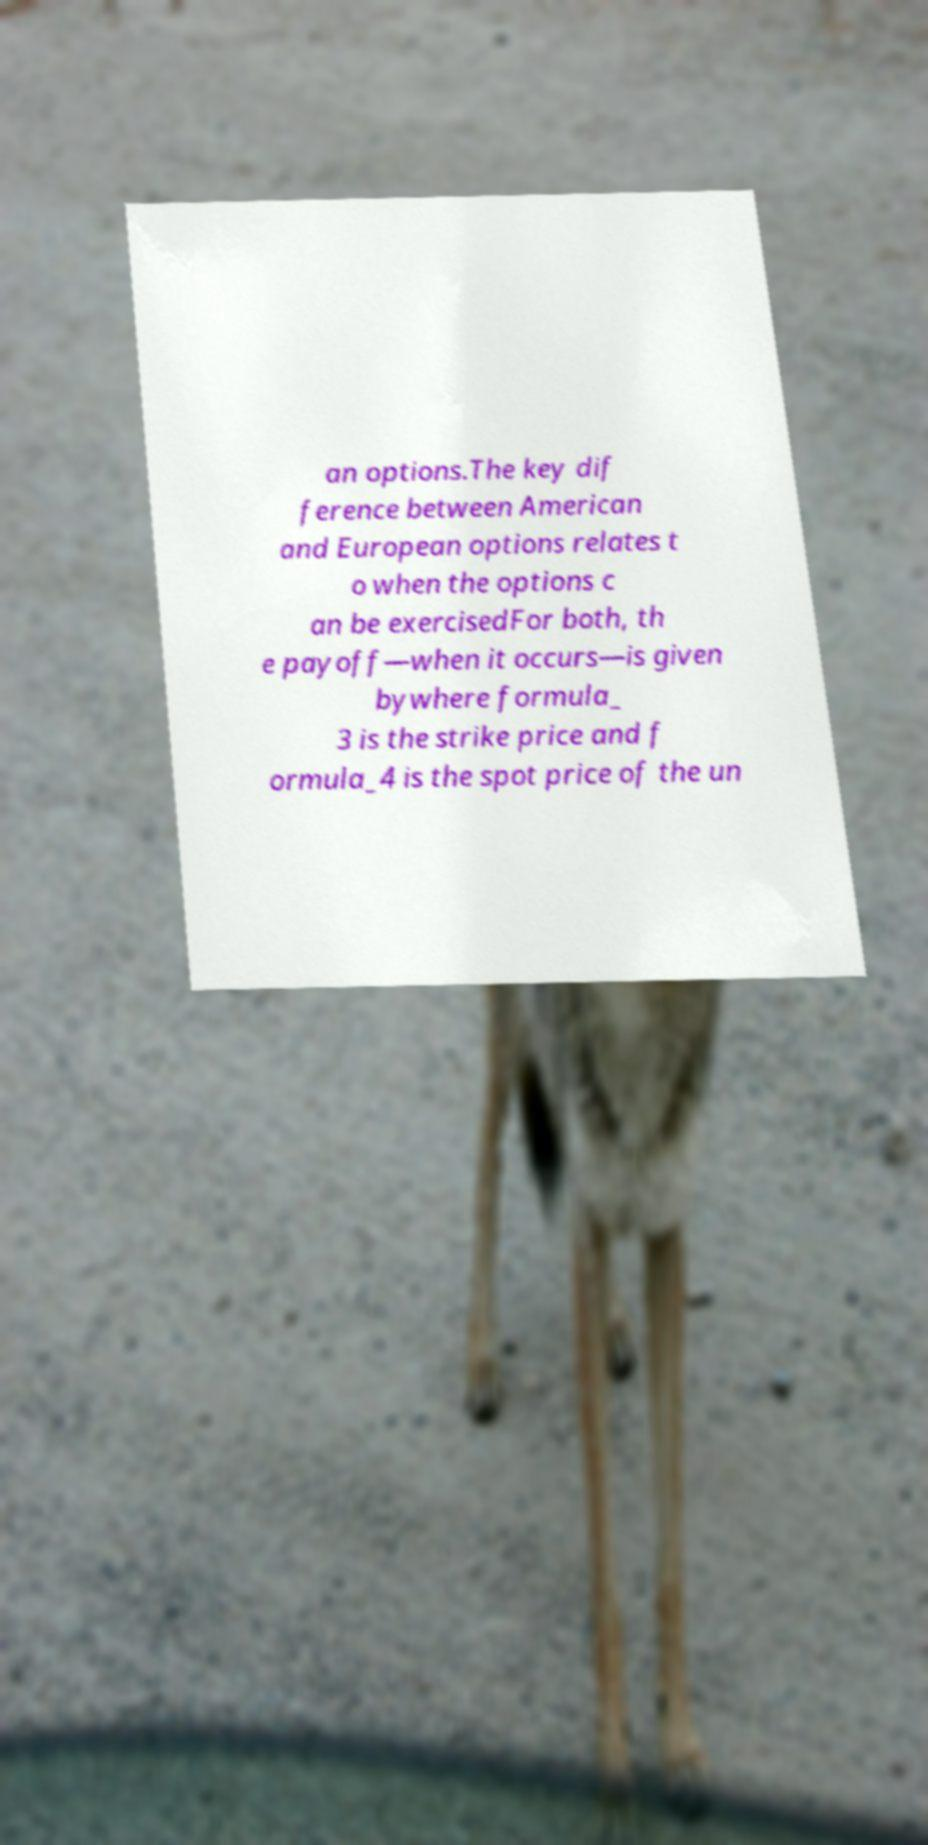Could you assist in decoding the text presented in this image and type it out clearly? an options.The key dif ference between American and European options relates t o when the options c an be exercisedFor both, th e payoff—when it occurs—is given bywhere formula_ 3 is the strike price and f ormula_4 is the spot price of the un 